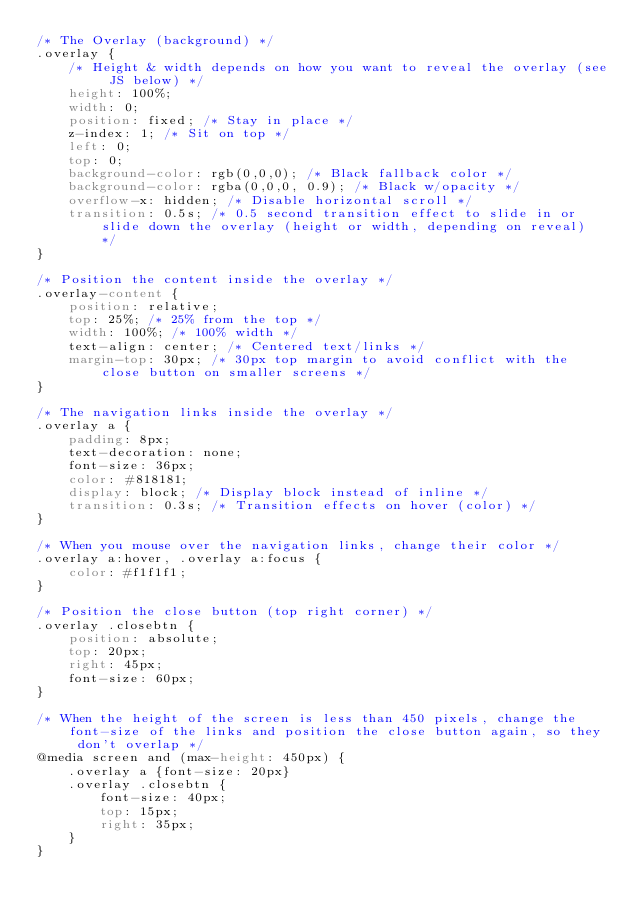<code> <loc_0><loc_0><loc_500><loc_500><_CSS_>/* The Overlay (background) */
.overlay {
    /* Height & width depends on how you want to reveal the overlay (see JS below) */
    height: 100%;
    width: 0;
    position: fixed; /* Stay in place */
    z-index: 1; /* Sit on top */
    left: 0;
    top: 0;
    background-color: rgb(0,0,0); /* Black fallback color */
    background-color: rgba(0,0,0, 0.9); /* Black w/opacity */
    overflow-x: hidden; /* Disable horizontal scroll */
    transition: 0.5s; /* 0.5 second transition effect to slide in or slide down the overlay (height or width, depending on reveal) */
}

/* Position the content inside the overlay */
.overlay-content {
    position: relative;
    top: 25%; /* 25% from the top */
    width: 100%; /* 100% width */
    text-align: center; /* Centered text/links */
    margin-top: 30px; /* 30px top margin to avoid conflict with the close button on smaller screens */
}

/* The navigation links inside the overlay */
.overlay a {
    padding: 8px;
    text-decoration: none;
    font-size: 36px;
    color: #818181;
    display: block; /* Display block instead of inline */
    transition: 0.3s; /* Transition effects on hover (color) */
}

/* When you mouse over the navigation links, change their color */
.overlay a:hover, .overlay a:focus {
    color: #f1f1f1;
}

/* Position the close button (top right corner) */
.overlay .closebtn {
    position: absolute;
    top: 20px;
    right: 45px;
    font-size: 60px;
}

/* When the height of the screen is less than 450 pixels, change the font-size of the links and position the close button again, so they don't overlap */
@media screen and (max-height: 450px) {
    .overlay a {font-size: 20px}
    .overlay .closebtn {
        font-size: 40px;
        top: 15px;
        right: 35px;
    }
}
</code> 